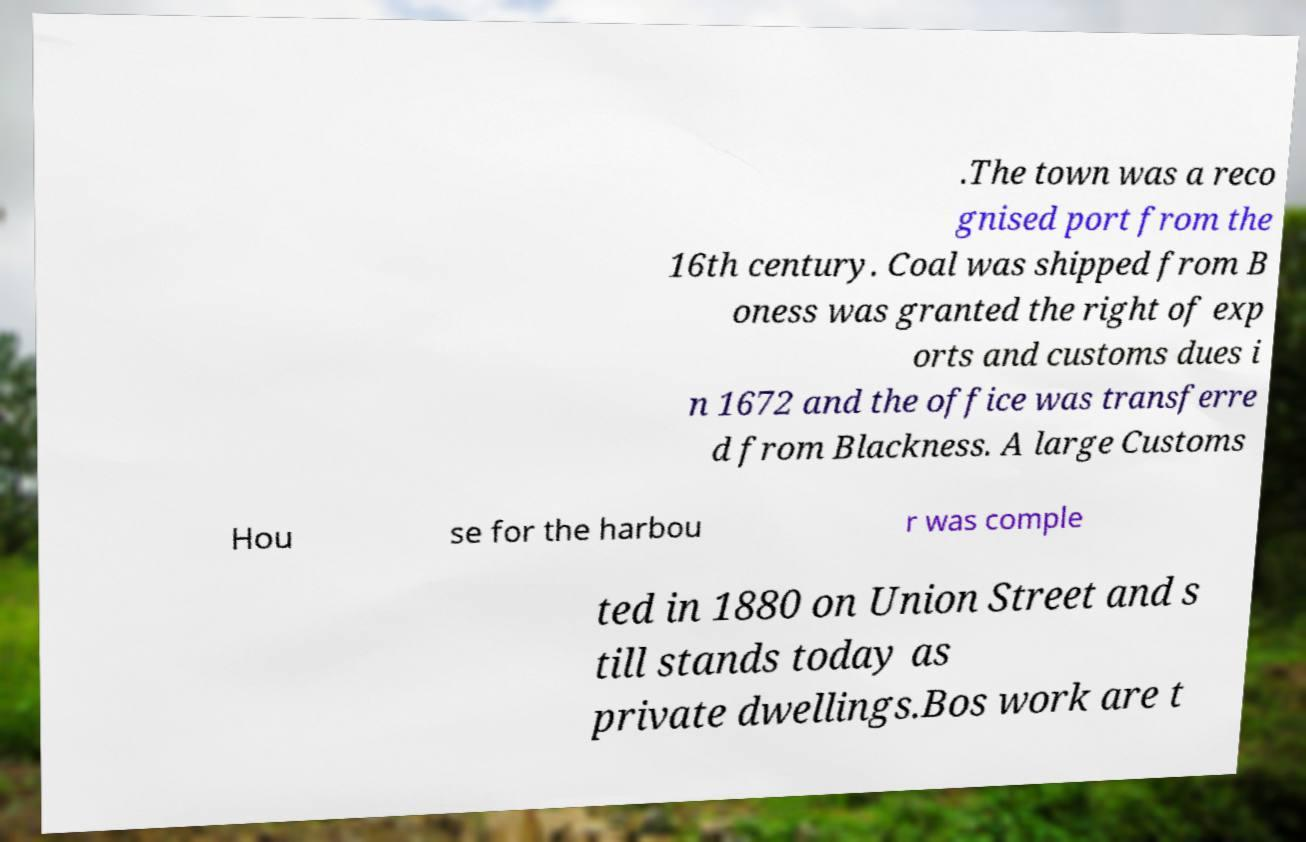I need the written content from this picture converted into text. Can you do that? .The town was a reco gnised port from the 16th century. Coal was shipped from B oness was granted the right of exp orts and customs dues i n 1672 and the office was transferre d from Blackness. A large Customs Hou se for the harbou r was comple ted in 1880 on Union Street and s till stands today as private dwellings.Bos work are t 